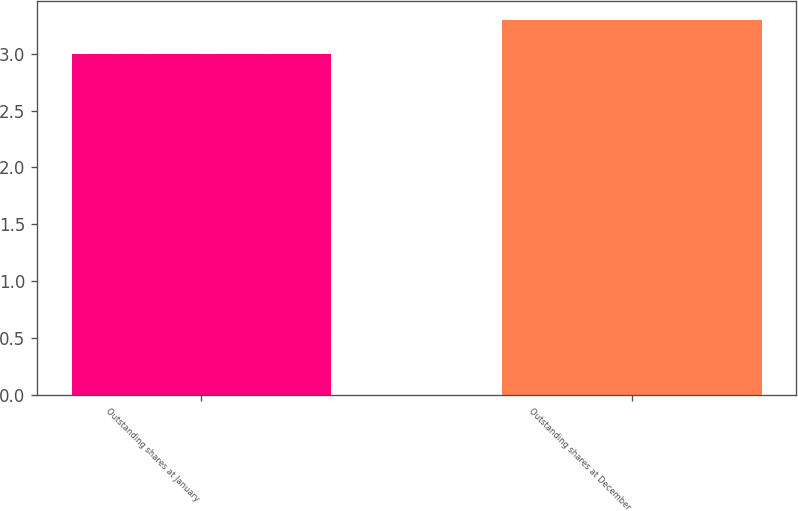Convert chart. <chart><loc_0><loc_0><loc_500><loc_500><bar_chart><fcel>Outstanding shares at January<fcel>Outstanding shares at December<nl><fcel>3<fcel>3.3<nl></chart> 